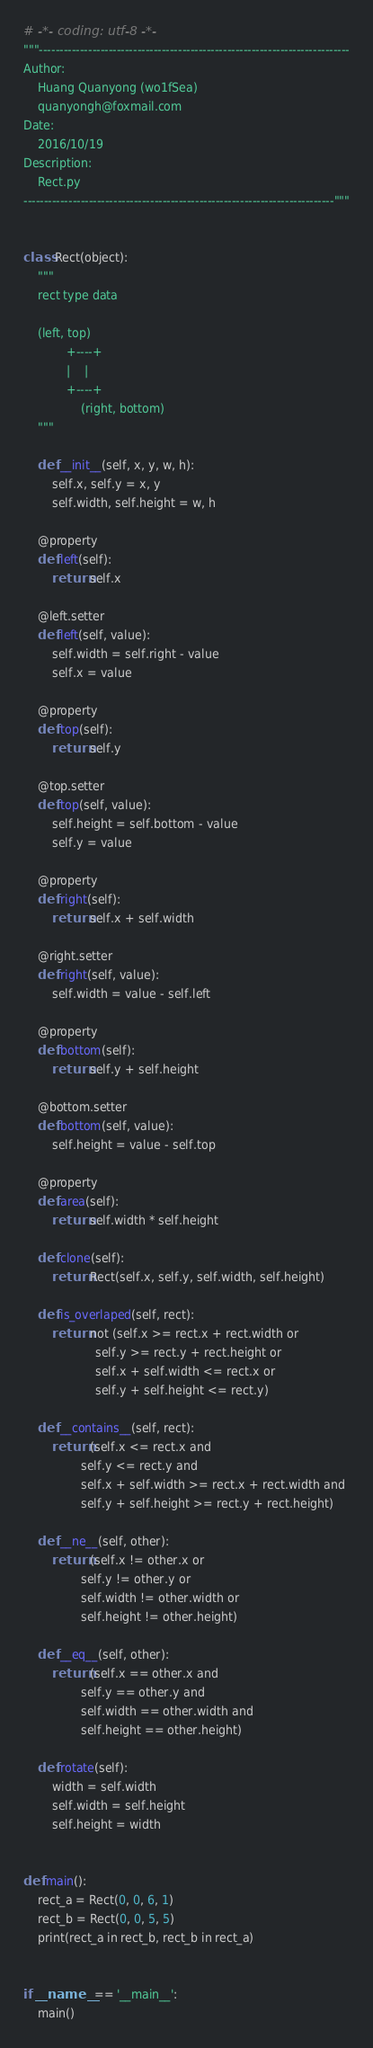<code> <loc_0><loc_0><loc_500><loc_500><_Python_># -*- coding: utf-8 -*-
"""----------------------------------------------------------------------------
Author:
    Huang Quanyong (wo1fSea)
    quanyongh@foxmail.com
Date:
    2016/10/19
Description:
    Rect.py
----------------------------------------------------------------------------"""


class Rect(object):
    """
    rect type data

    (left, top)
            +----+
            |    |
            +----+
                (right, bottom)
    """

    def __init__(self, x, y, w, h):
        self.x, self.y = x, y
        self.width, self.height = w, h

    @property
    def left(self):
        return self.x

    @left.setter
    def left(self, value):
        self.width = self.right - value
        self.x = value

    @property
    def top(self):
        return self.y

    @top.setter
    def top(self, value):
        self.height = self.bottom - value
        self.y = value

    @property
    def right(self):
        return self.x + self.width

    @right.setter
    def right(self, value):
        self.width = value - self.left

    @property
    def bottom(self):
        return self.y + self.height

    @bottom.setter
    def bottom(self, value):
        self.height = value - self.top

    @property
    def area(self):
        return self.width * self.height

    def clone(self):
        return Rect(self.x, self.y, self.width, self.height)

    def is_overlaped(self, rect):
        return not (self.x >= rect.x + rect.width or
                    self.y >= rect.y + rect.height or
                    self.x + self.width <= rect.x or
                    self.y + self.height <= rect.y)

    def __contains__(self, rect):
        return (self.x <= rect.x and
                self.y <= rect.y and
                self.x + self.width >= rect.x + rect.width and
                self.y + self.height >= rect.y + rect.height)

    def __ne__(self, other):
        return (self.x != other.x or
                self.y != other.y or
                self.width != other.width or
                self.height != other.height)

    def __eq__(self, other):
        return (self.x == other.x and
                self.y == other.y and
                self.width == other.width and
                self.height == other.height)

    def rotate(self):
        width = self.width
        self.width = self.height
        self.height = width


def main():
    rect_a = Rect(0, 0, 6, 1)
    rect_b = Rect(0, 0, 5, 5)
    print(rect_a in rect_b, rect_b in rect_a)


if __name__ == '__main__':
    main()
</code> 